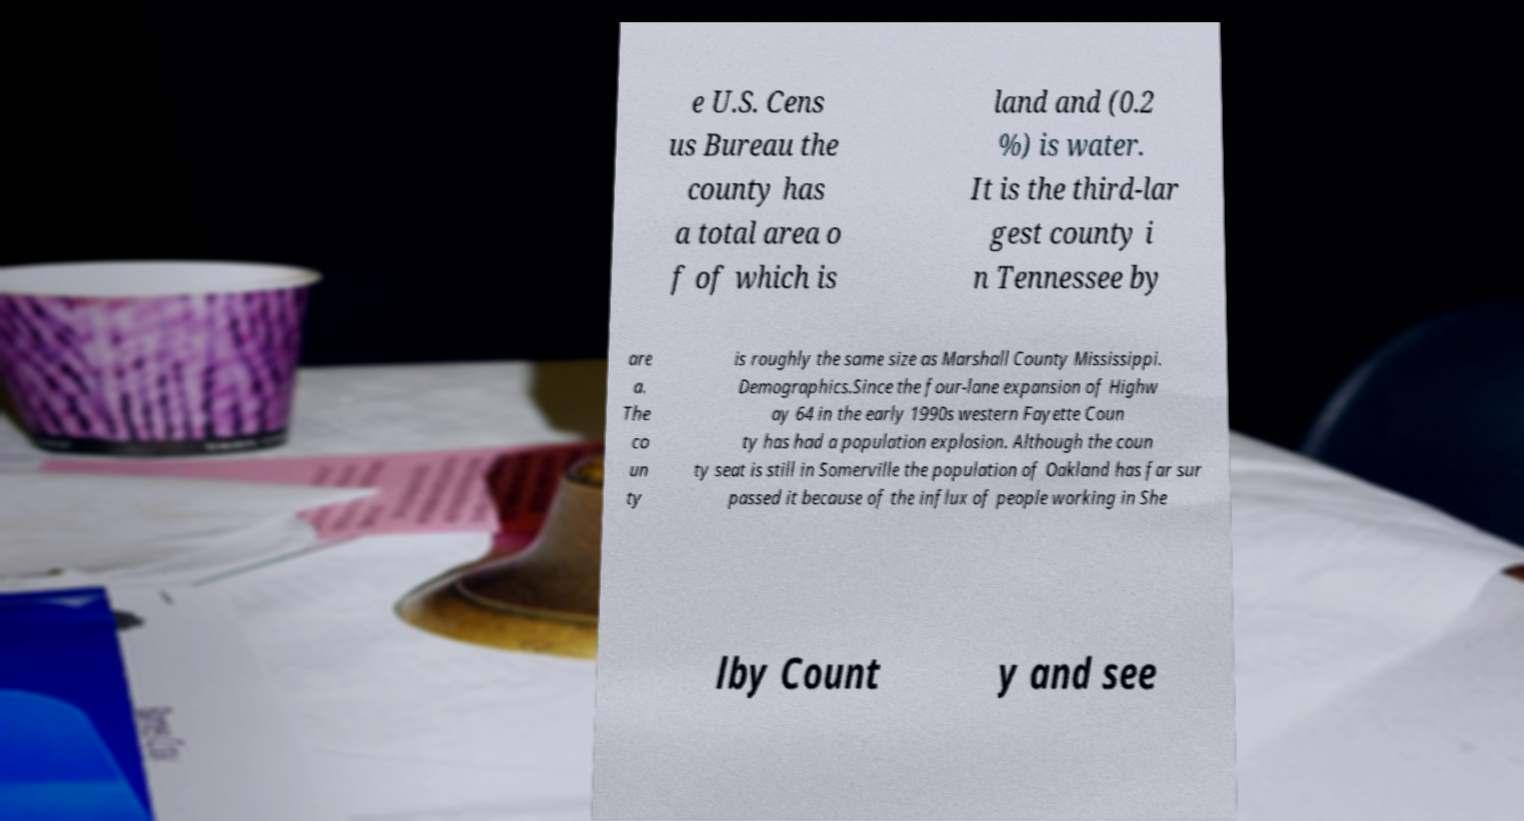Can you read and provide the text displayed in the image?This photo seems to have some interesting text. Can you extract and type it out for me? e U.S. Cens us Bureau the county has a total area o f of which is land and (0.2 %) is water. It is the third-lar gest county i n Tennessee by are a. The co un ty is roughly the same size as Marshall County Mississippi. Demographics.Since the four-lane expansion of Highw ay 64 in the early 1990s western Fayette Coun ty has had a population explosion. Although the coun ty seat is still in Somerville the population of Oakland has far sur passed it because of the influx of people working in She lby Count y and see 